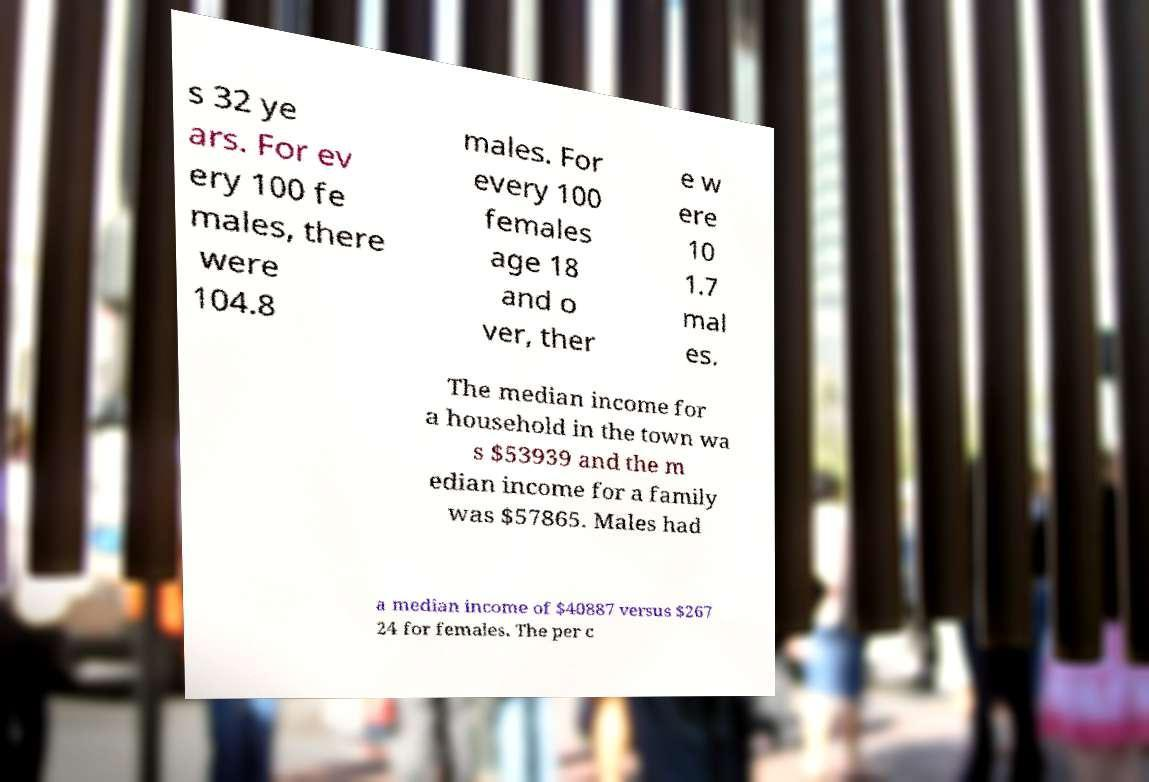Please read and relay the text visible in this image. What does it say? s 32 ye ars. For ev ery 100 fe males, there were 104.8 males. For every 100 females age 18 and o ver, ther e w ere 10 1.7 mal es. The median income for a household in the town wa s $53939 and the m edian income for a family was $57865. Males had a median income of $40887 versus $267 24 for females. The per c 